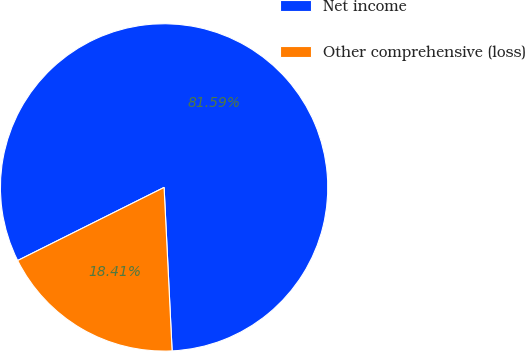<chart> <loc_0><loc_0><loc_500><loc_500><pie_chart><fcel>Net income<fcel>Other comprehensive (loss)<nl><fcel>81.59%<fcel>18.41%<nl></chart> 